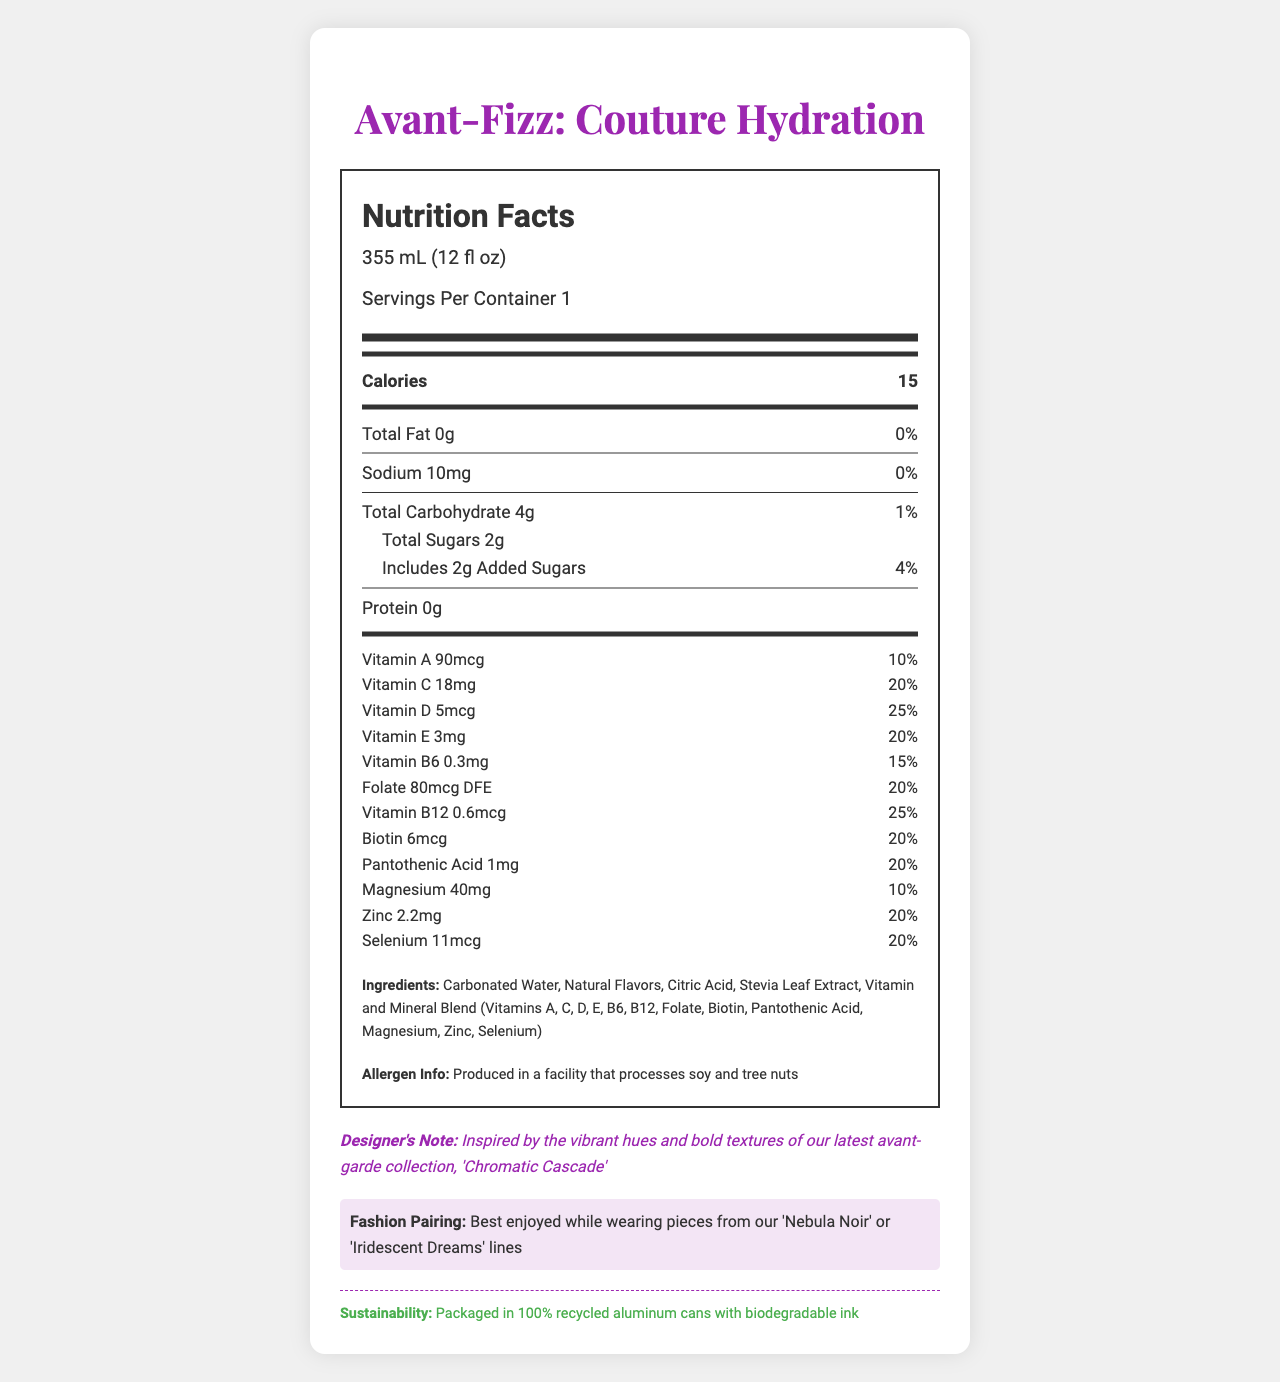what is the serving size for "Avant-Fizz: Couture Hydration"? The serving size is clearly listed as "355 mL (12 fl oz)" in the document.
Answer: 355 mL (12 fl oz) How many calories are in one serving? The calories per serving are listed as "15" in the document.
Answer: 15 What percentage of the daily value for Vitamin C does one serving provide? According to the document, one serving provides "20%" of the daily value for Vitamin C.
Answer: 20% List any two vitamins included in the "Vitamin and Mineral Blend". The ingredients list shows that the "Vitamin and Mineral Blend" includes "(Vitamins A, C, D, E, B6, B12, Folate, Biotin, Pantothenic Acid, Magnesium, Zinc, Selenium)".
Answer: Vitamin A, Vitamin B12 Does the product contain any protein? The nutrient information indicates that the protein content is "0g".
Answer: No What is the daily value for total carbohydrates in one serving? The document states that the daily value for total carbohydrates is "1%".
Answer: 1% Which of these minerals is present in the drink? A. Calcium B. Magnesium C. Potassium D. Iron The document lists "Magnesium" but does not mention Calcium, Potassium, or Iron.
Answer: B. Magnesium How much added sugar is in one serving? A. 1g B. 2g C. 3g D. 4g The total added sugars in one serving are "2g" as per the document.
Answer: B. 2g Is "Avant-Fizz: Couture Hydration" produced in a facility that processes soy? The allergen information states that it is "Produced in a facility that processes soy and tree nuts."
Answer: Yes Summarize the main features of "Avant-Fizz: Couture Hydration". The summary covers nutritional details, vitamin and mineral content, inspiration, and sustainability aspects as presented in the document.
Answer: "Avant-Fizz: Couture Hydration" is a vitamin-enriched sparkling water with 15 calories per 355 mL serving. It contains various vitamins and minerals such as Vitamins A, C, D, E, B6, B12, magnesium, and zinc. The product has minimal sodium and carbohydrates and is sweetened with stevia leaf extract. It is inspired by avant-garde fashion collections and packaged sustainably. How much vitamin D is in one serving? The document specifies that there are "5mcg" of Vitamin D per serving.
Answer: 5mcg Is there any detailed nutritional information provided for natural flavors? The document lists "Natural Flavors" as an ingredient but does not provide detailed nutritional information for it.
Answer: No What inspired the design of this product? The designer note mentions that the product was inspired by the "vibrant hues and bold textures of our latest avant-garde collection, 'Chromatic Cascade'".
Answer: The vibrant hues and bold textures of the latest avant-garde collection, 'Chromatic Cascade' Which fashion lines pair best with this product? The fashion pairing section of the document suggests that the product is best enjoyed while wearing pieces from the "Nebula Noir" or "Iridescent Dreams" lines.
Answer: 'Nebula Noir' or 'Iridescent Dreams' What is the sustainability claim made about the packaging? The sustainability statement in the document claims that the product is "Packaged in 100% recycled aluminum cans with biodegradable ink".
Answer: Packaged in 100% recycled aluminum cans with biodegradable ink What is the percentage of daily value for zinc in one serving? According to the document, one serving provides "20%" of the daily value for zinc.
Answer: 20% What color is the background commonly used in the visual design of this document? The design of the document includes a "background color: #fff" which translates to white.
Answer: White 